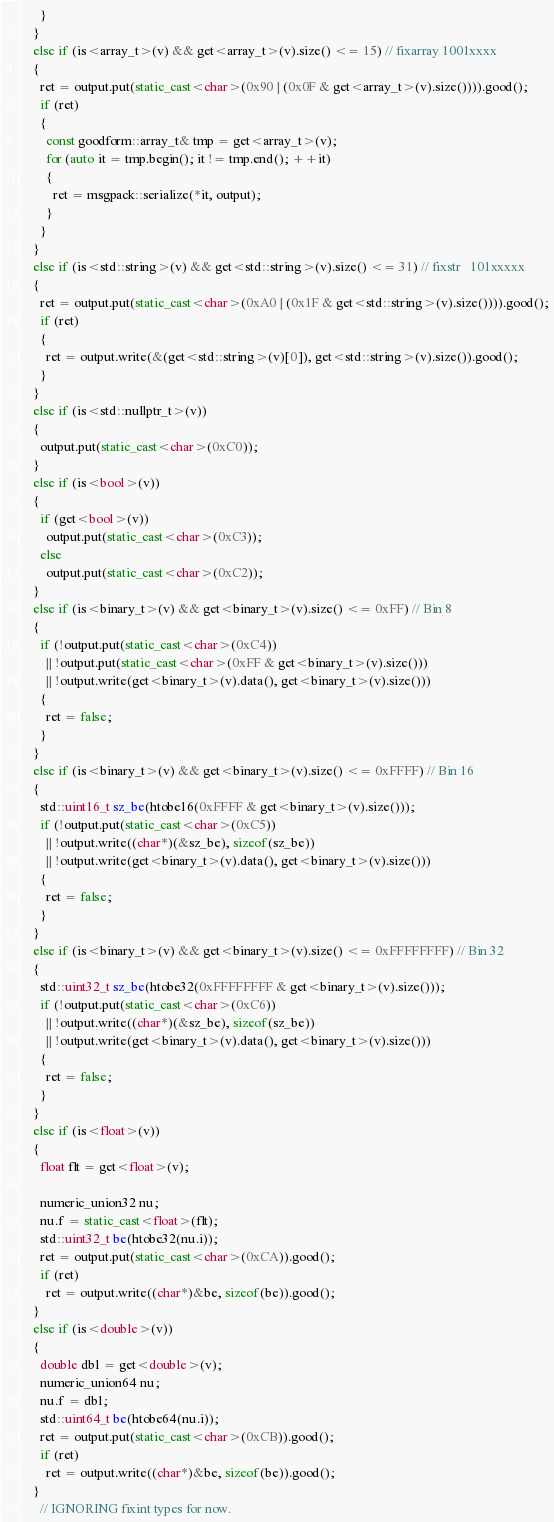<code> <loc_0><loc_0><loc_500><loc_500><_C++_>      }
    }
    else if (is<array_t>(v) && get<array_t>(v).size() <= 15) // fixarray	1001xxxx
    {
      ret = output.put(static_cast<char>(0x90 | (0x0F & get<array_t>(v).size()))).good();
      if (ret)
      {
        const goodform::array_t& tmp = get<array_t>(v);
        for (auto it = tmp.begin(); it != tmp.end(); ++it)
        {
          ret = msgpack::serialize(*it, output);
        }
      }
    }
    else if (is<std::string>(v) && get<std::string>(v).size() <= 31) // fixstr	101xxxxx
    {
      ret = output.put(static_cast<char>(0xA0 | (0x1F & get<std::string>(v).size()))).good();
      if (ret)
      {
        ret = output.write(&(get<std::string>(v)[0]), get<std::string>(v).size()).good();
      }
    }
    else if (is<std::nullptr_t>(v))
    {
      output.put(static_cast<char>(0xC0));
    }
    else if (is<bool>(v))
    {
      if (get<bool>(v))
        output.put(static_cast<char>(0xC3));
      else
        output.put(static_cast<char>(0xC2));
    }
    else if (is<binary_t>(v) && get<binary_t>(v).size() <= 0xFF) // Bin 8
    {
      if (!output.put(static_cast<char>(0xC4))
        || !output.put(static_cast<char>(0xFF & get<binary_t>(v).size()))
        || !output.write(get<binary_t>(v).data(), get<binary_t>(v).size()))
      {
        ret = false;
      }
    }
    else if (is<binary_t>(v) && get<binary_t>(v).size() <= 0xFFFF) // Bin 16
    {
      std::uint16_t sz_be(htobe16(0xFFFF & get<binary_t>(v).size()));
      if (!output.put(static_cast<char>(0xC5))
        || !output.write((char*)(&sz_be), sizeof(sz_be))
        || !output.write(get<binary_t>(v).data(), get<binary_t>(v).size()))
      {
        ret = false;
      }
    }
    else if (is<binary_t>(v) && get<binary_t>(v).size() <= 0xFFFFFFFF) // Bin 32
    {
      std::uint32_t sz_be(htobe32(0xFFFFFFFF & get<binary_t>(v).size()));
      if (!output.put(static_cast<char>(0xC6))
        || !output.write((char*)(&sz_be), sizeof(sz_be))
        || !output.write(get<binary_t>(v).data(), get<binary_t>(v).size()))
      {
        ret = false;
      }
    }
    else if (is<float>(v))
    {
      float flt = get<float>(v);

      numeric_union32 nu;
      nu.f = static_cast<float>(flt);
      std::uint32_t be(htobe32(nu.i));
      ret = output.put(static_cast<char>(0xCA)).good();
      if (ret)
        ret = output.write((char*)&be, sizeof(be)).good();
    }
    else if (is<double>(v))
    {
      double dbl = get<double>(v);
      numeric_union64 nu;
      nu.f = dbl;
      std::uint64_t be(htobe64(nu.i));
      ret = output.put(static_cast<char>(0xCB)).good();
      if (ret)
        ret = output.write((char*)&be, sizeof(be)).good();
    }
      // IGNORING fixint types for now.</code> 